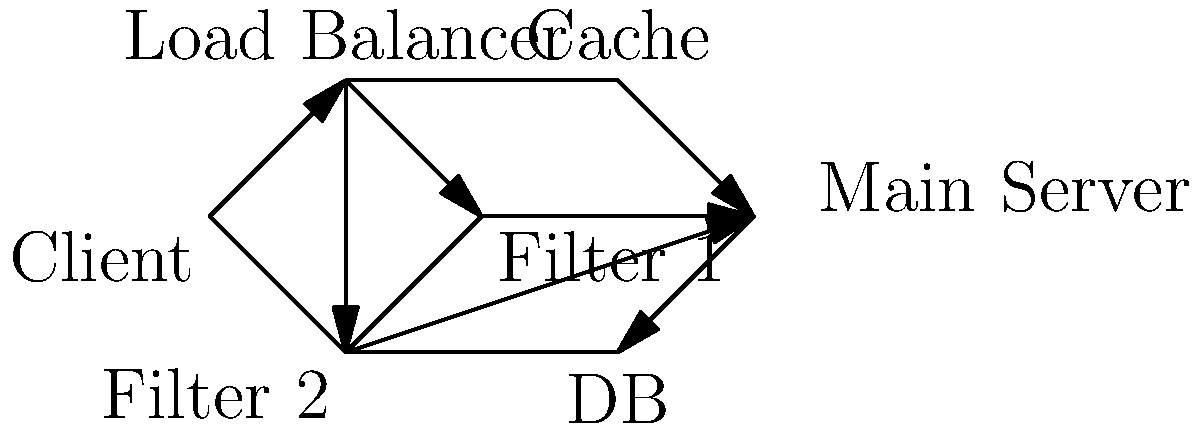In the context of a real-time content filtering system for a spoiler-blocking app, analyze the network architecture shown in the diagram. How would implementing a cache (node E) affect the overall latency of the system compared to a direct connection between the load balancer (node B) and the main server (node F)? Assume that 60% of requests can be served from the cache. To analyze the impact of the cache on latency, we need to consider the following steps:

1. Without cache:
   - All requests go through: Client → Load Balancer → Filter → Main Server
   - Let's assume average latency for this path is $L_{orig}$

2. With cache:
   - 60% of requests: Client → Load Balancer → Cache
   - 40% of requests: Client → Load Balancer → Filter → Main Server
   - Let's assume average latency for cache hits is $L_{cache}$, where $L_{cache} < L_{orig}$

3. Calculate the average latency with cache:
   $L_{avg} = 0.6 \times L_{cache} + 0.4 \times L_{orig}$

4. The difference in latency:
   $\Delta L = L_{orig} - L_{avg}$
   $\Delta L = L_{orig} - (0.6 \times L_{cache} + 0.4 \times L_{orig})$
   $\Delta L = 0.6 \times (L_{orig} - L_{cache})$

5. Since $L_{cache} < L_{orig}$, $\Delta L$ is positive, indicating a reduction in average latency.

6. The latency reduction is proportional to the cache hit rate (60% in this case) and the difference between original and cache latency.

7. Additional benefits:
   - Reduced load on the main server and database
   - Improved scalability of the system
   - Potential for faster updates to the filtering rules

8. Potential drawbacks:
   - Increased complexity in maintaining cache consistency
   - Additional hardware/software costs for cache implementation
   - Slight increase in latency for cache misses due to the extra hop

In the context of a spoiler-blocking app, this architecture can significantly improve the real-time performance of content filtering, especially for popular or trending content that is likely to be cached.
Answer: The cache reduces average latency by $0.6 \times (L_{orig} - L_{cache})$, improving real-time filtering performance. 